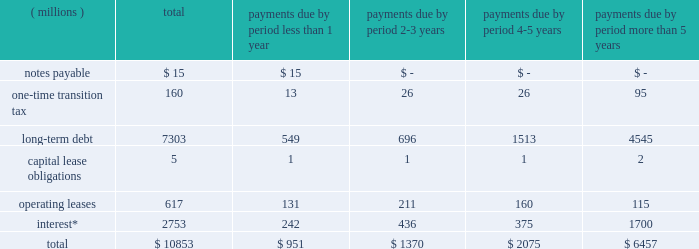Liquidity and capital resources we currently expect to fund all of our cash requirements which are reasonably foreseeable for 2018 , including scheduled debt repayments , new investments in the business , share repurchases , dividend payments , possible business acquisitions and pension contributions , with cash from operating activities , and as needed , additional short-term and/or long-term borrowings .
We continue to expect our operating cash flow to remain strong .
As of december 31 , 2017 , we had $ 211 million of cash and cash equivalents on hand , of which $ 151 million was held outside of the as of december 31 , 2016 , we had $ 327 million of cash and cash equivalents on hand , of which $ 184 million was held outside of the u.s .
As of december 31 , 2015 , we had $ 26 million of deferred tax liabilities for pre-acquisition foreign earnings associated with the legacy nalco entities and legacy champion entities that we intended to repatriate .
These liabilities were recorded as part of the respective purchase price accounting of each transaction .
The remaining foreign earnings were repatriated in 2016 , reducing the deferred tax liabilities to zero at december 31 , 2016 .
As of december 31 , 2017 we had a $ 2.0 billion multi-year credit facility , which expires in november 2022 .
The credit facility has been established with a diverse syndicate of banks .
There were no borrowings under our credit facility as of december 31 , 2017 or 2016 .
The credit facility supports our $ 2.0 billion u.s .
Commercial paper program and $ 2.0 billion european commercial paper program .
Combined borrowing under these two commercial paper programs may not exceed $ 2.0 billion .
At year-end , we had no amount outstanding under the european commercial paper program and no amount outstanding under the u.s .
Commercial paper program .
Additionally , we have uncommitted credit lines of $ 660 million with major international banks and financial institutions to support our general global funding needs .
Most of these lines are used to support global cash pooling structures .
Approximately $ 643 million of these credit lines were available for use as of year-end 2017 .
Bank supported letters of credit , surety bonds and guarantees total $ 198 million and represent commercial business transactions .
We do not have any other significant unconditional purchase obligations or commercial commitments .
As of december 31 , 2017 , our short-term borrowing program was rated a-2 by standard & poor 2019s and p-2 by moody 2019s .
As of december 31 , 2017 , standard & poor 2019s and moody 2019s rated our long-term credit at a- ( stable outlook ) and baa1 ( stable outlook ) , respectively .
A reduction in our credit ratings could limit or preclude our ability to issue commercial paper under our current programs , or could also adversely affect our ability to renew existing , or negotiate new , credit facilities in the future and could increase the cost of these facilities .
Should this occur , we could seek additional sources of funding , including issuing additional term notes or bonds .
In addition , we have the ability , at our option , to draw upon our $ 2.0 billion of committed credit facility .
We are in compliance with our debt covenants and other requirements of our credit agreements and indentures .
A schedule of our various obligations as of december 31 , 2017 are summarized in the table: .
* interest on variable rate debt was calculated using the interest rate at year-end 2017 .
During the fourth quarter of 2017 , we recorded a one-time transition tax related to enactment of the tax act .
The expense is primarily related to the one-time transition tax , which is payable over eight years .
As discussed further in note 12 , this balance is a provisional amount and is subject to adjustment during the measurement period of up to one year following the enactment of the tax act , as provided by recent sec guidance .
As of december 31 , 2017 , our gross liability for uncertain tax positions was $ 68 million .
We are not able to reasonably estimate the amount by which the liability will increase or decrease over an extended period of time or whether a cash settlement of the liability will be required .
Therefore , these amounts have been excluded from the schedule of contractual obligations. .
What percent of the one-time transition tax is due in les than one year? 
Computations: (13 / 160)
Answer: 0.08125. 